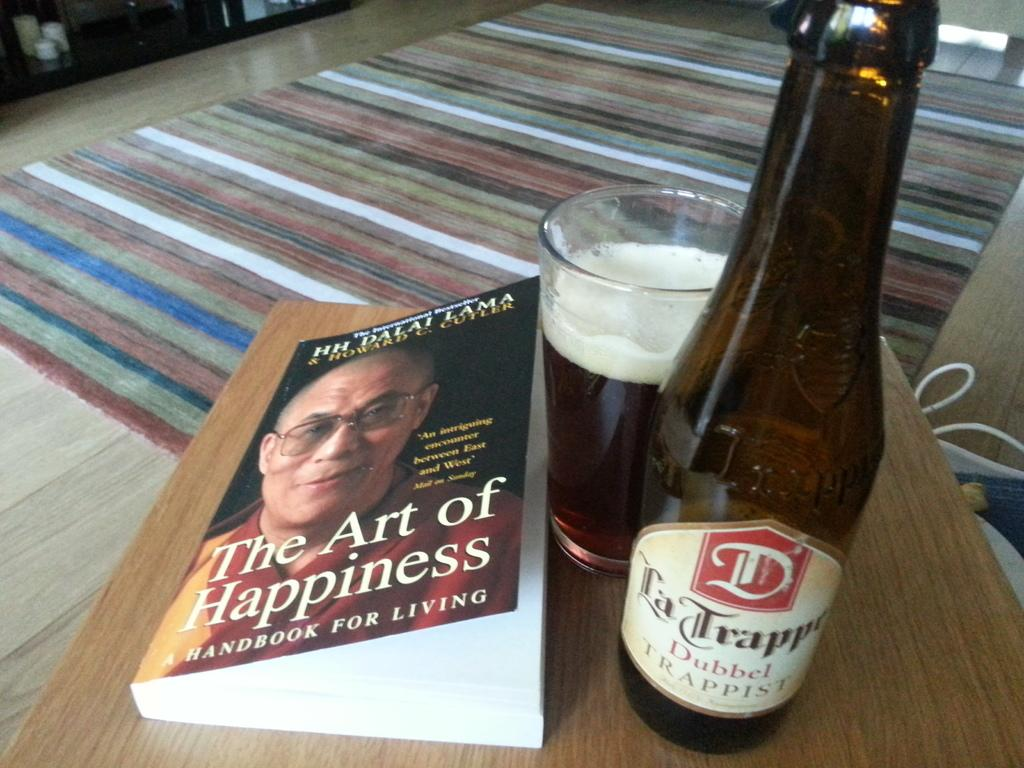What object can be seen in the image that is typically used for reading? There is a book in the image that is typically used for reading. What object in the image might be used for drinking? There is a glass in the image that might be used for drinking. What other object in the image might be used for holding a liquid? There is a bottle in the image that might be used for holding a liquid. What type of gold jewelry is visible on the book in the image? There is no gold jewelry present on the book in the image. What name is written on the glass in the image? There is no name written on the glass in the image. 